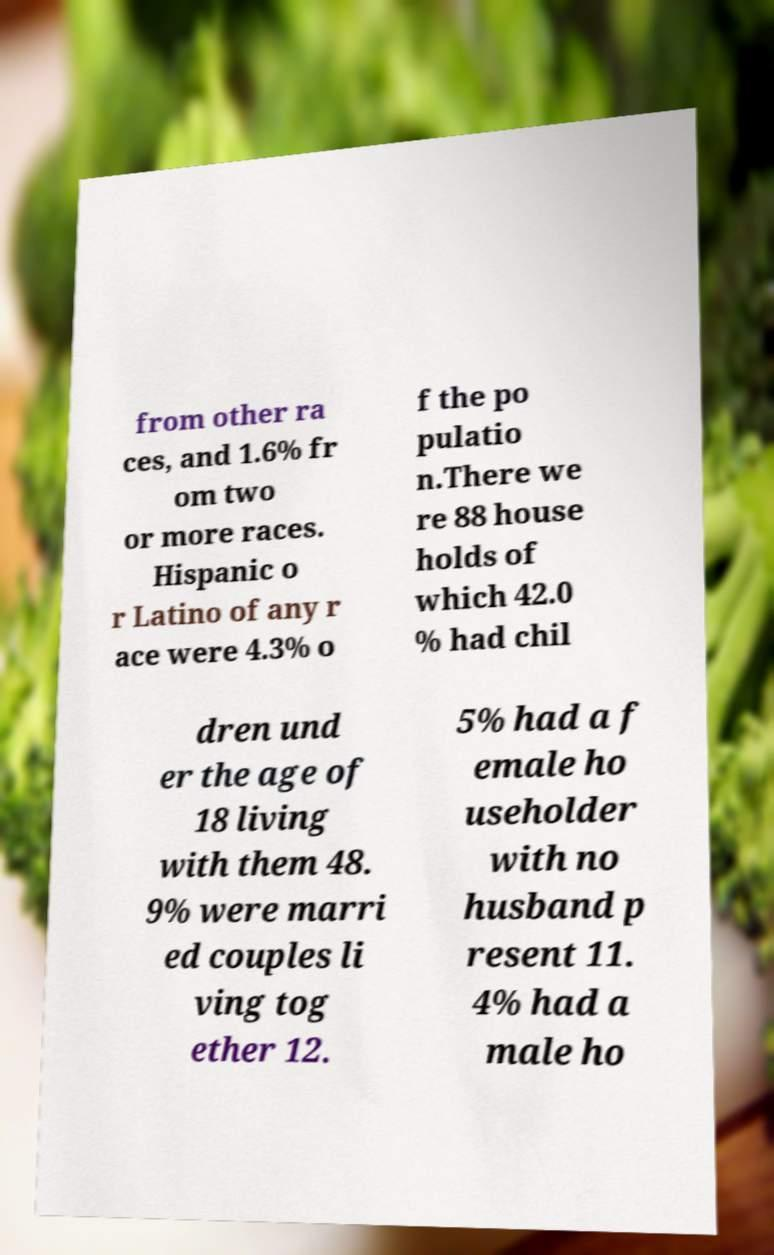For documentation purposes, I need the text within this image transcribed. Could you provide that? from other ra ces, and 1.6% fr om two or more races. Hispanic o r Latino of any r ace were 4.3% o f the po pulatio n.There we re 88 house holds of which 42.0 % had chil dren und er the age of 18 living with them 48. 9% were marri ed couples li ving tog ether 12. 5% had a f emale ho useholder with no husband p resent 11. 4% had a male ho 